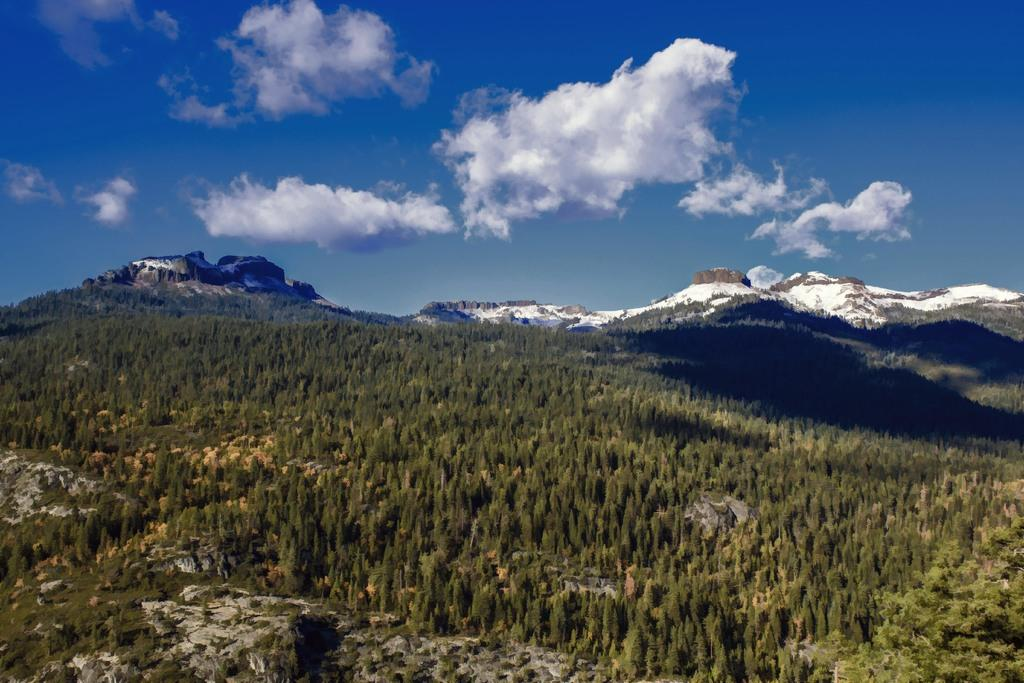What type of living organisms can be seen in the image? Plants can be seen in the image. What geographical feature is present in the image? There is a mountain in the image. What is visible in the background of the image? The sky is visible in the background of the image. What can be seen in the sky? There are clouds in the sky. What type of suit is the dog wearing in the image? There is no dog or suit present in the image. How many mint leaves can be seen on the mountain in the image? There are no mint leaves visible in the image; it features plants, a mountain, and clouds in the sky. 